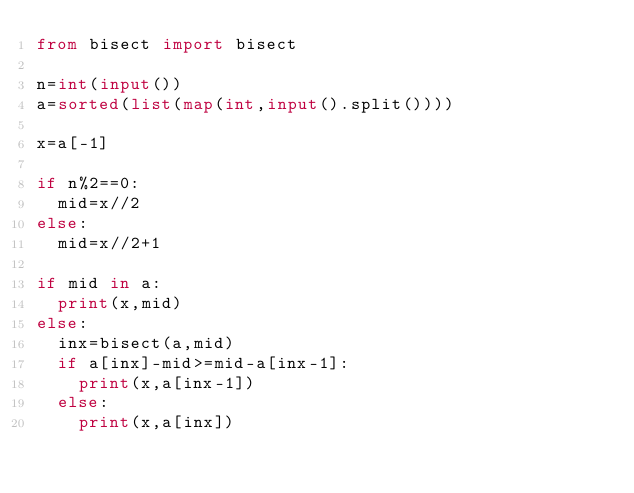Convert code to text. <code><loc_0><loc_0><loc_500><loc_500><_Python_>from bisect import bisect

n=int(input())
a=sorted(list(map(int,input().split())))

x=a[-1]

if n%2==0:
  mid=x//2
else:
  mid=x//2+1

if mid in a:
  print(x,mid)
else:
  inx=bisect(a,mid)
  if a[inx]-mid>=mid-a[inx-1]:
    print(x,a[inx-1])
  else:
    print(x,a[inx])</code> 